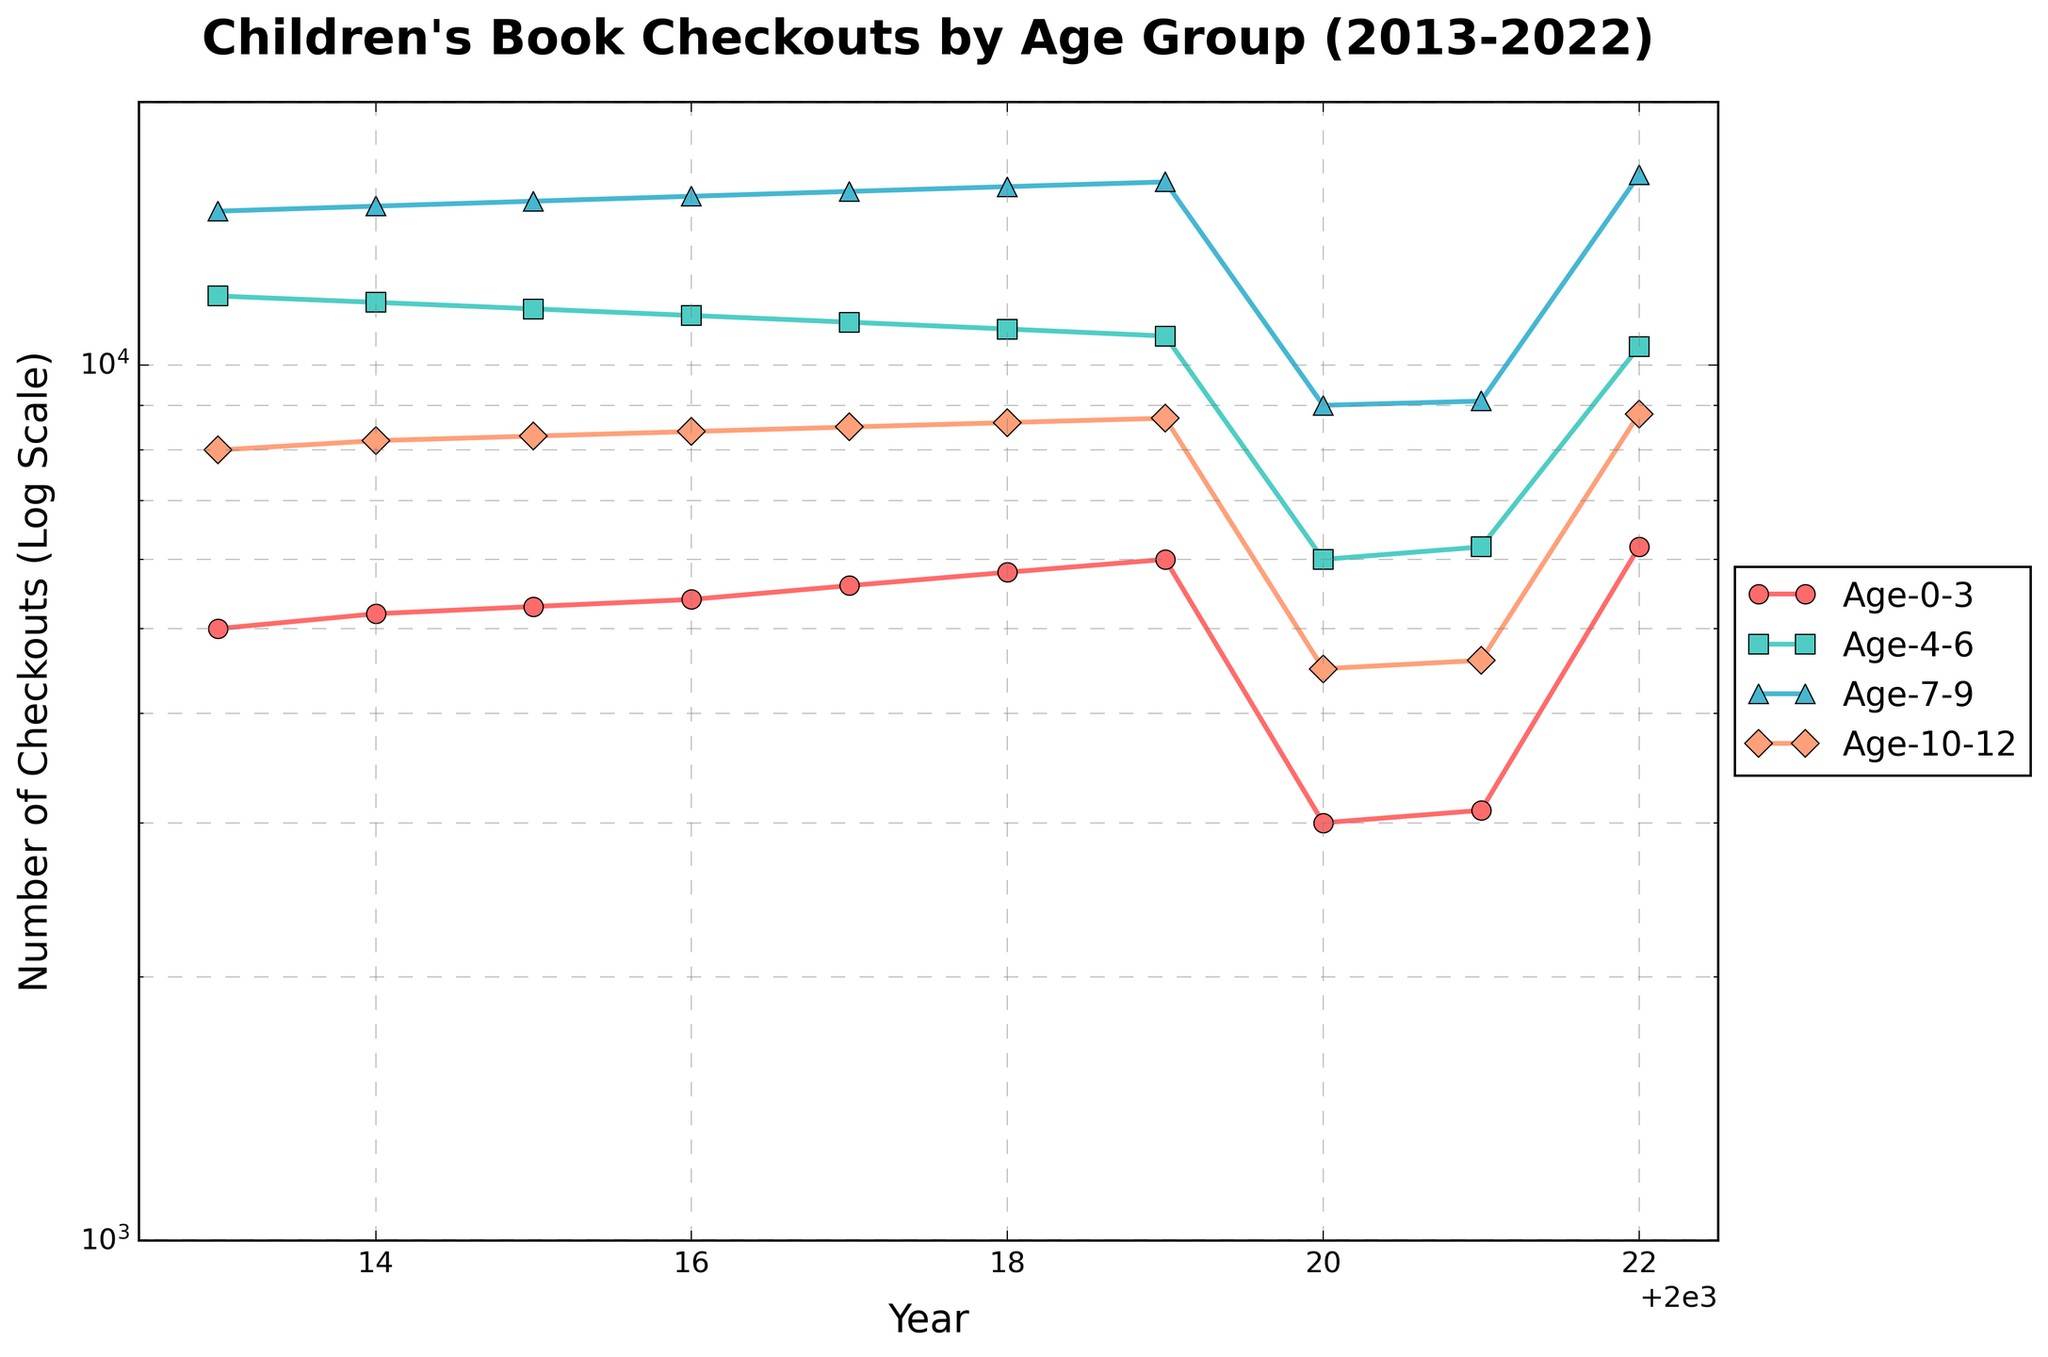What's the title of the figure? The title of the figure is located at the top center of the plot and clearly states the subject.
Answer: Children's Book Checkouts by Age Group (2013-2022) What is the y-axis representing? The y-axis represents the number of book checkouts, and it uses a logarithmic scale to accommodate the wide range of values.
Answer: Number of Checkouts (Log Scale) What trend can be observed for the Age_7_9 group over the years? By following the line for the Age_7_9 group, it can be observed that there is a general increasing trend from 2013 to 2019, followed by a dip in 2020 and 2021, and then a recovery in 2022.
Answer: Increasing trend with a dip in 2020 and 2021 Which year saw the highest number of checkouts for the Age_4_6 group? The peak point for the Age_4_6 group can be visually identified on the graph.
Answer: 2013 Compare the checkouts in 2020 and 2022 for the oldest age group (Age_10_12). Comparing the vertical positions of the data points for Age_10_12 in 2020 and 2022 reveals a significant increase.
Answer: 2022 shows a significant increase compared to 2020 What happened to the number of checkouts for all age groups in 2020? All age groups show a noticeable decrease in the number of checkouts in the year 2020. This is evident by comparing the data points of 2020 to adjacent years.
Answer: All age groups saw a decrease in 2020 By how much did the checkouts for the Age_0_3 group change from 2019 to 2020? Looking at the points on the graph for 2019 and 2020 for Age_0_3 and using the y-axis for reference, the checkouts approximately dropped from 6000 to 3000.
Answer: Dropped by about 3000 Which age group had the most stable checkout numbers over the decade? To determine stability, you can trace the lines for each age group and see which line has the most consistent level. The Age_10_12 group's line appears the most stable.
Answer: Age_10_12 How did the checkouts for the Age_0_3 group in 2022 compare to those in 2013? By comparing the starting and ending points of the Age_0_3 group's line, you see an increase from 5000 in 2013 to 6200 in 2022.
Answer: Increased by 1200 What is the general trend for library checkouts for children across all age groups from 2021 to 2022? Observing the lines from 2021 to 2022 for all age groups suggests a recovery or increase in the number of checkouts.
Answer: Increasing trend 